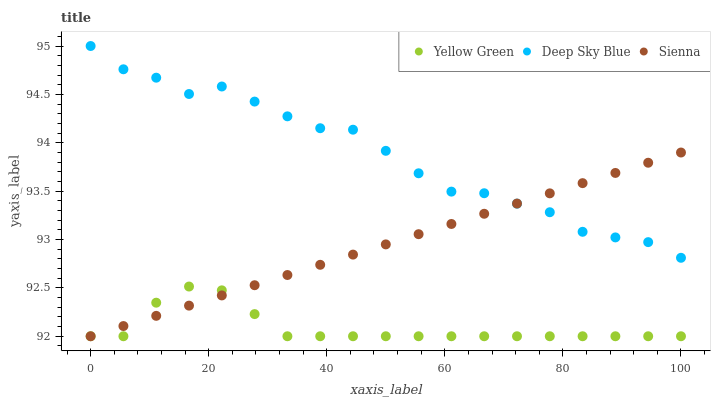Does Yellow Green have the minimum area under the curve?
Answer yes or no. Yes. Does Deep Sky Blue have the maximum area under the curve?
Answer yes or no. Yes. Does Deep Sky Blue have the minimum area under the curve?
Answer yes or no. No. Does Yellow Green have the maximum area under the curve?
Answer yes or no. No. Is Sienna the smoothest?
Answer yes or no. Yes. Is Deep Sky Blue the roughest?
Answer yes or no. Yes. Is Yellow Green the smoothest?
Answer yes or no. No. Is Yellow Green the roughest?
Answer yes or no. No. Does Sienna have the lowest value?
Answer yes or no. Yes. Does Deep Sky Blue have the lowest value?
Answer yes or no. No. Does Deep Sky Blue have the highest value?
Answer yes or no. Yes. Does Yellow Green have the highest value?
Answer yes or no. No. Is Yellow Green less than Deep Sky Blue?
Answer yes or no. Yes. Is Deep Sky Blue greater than Yellow Green?
Answer yes or no. Yes. Does Yellow Green intersect Sienna?
Answer yes or no. Yes. Is Yellow Green less than Sienna?
Answer yes or no. No. Is Yellow Green greater than Sienna?
Answer yes or no. No. Does Yellow Green intersect Deep Sky Blue?
Answer yes or no. No. 